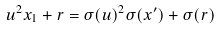Convert formula to latex. <formula><loc_0><loc_0><loc_500><loc_500>u ^ { 2 } x _ { 1 } + r = \sigma ( u ) ^ { 2 } \sigma ( x ^ { \prime } ) + \sigma ( r )</formula> 